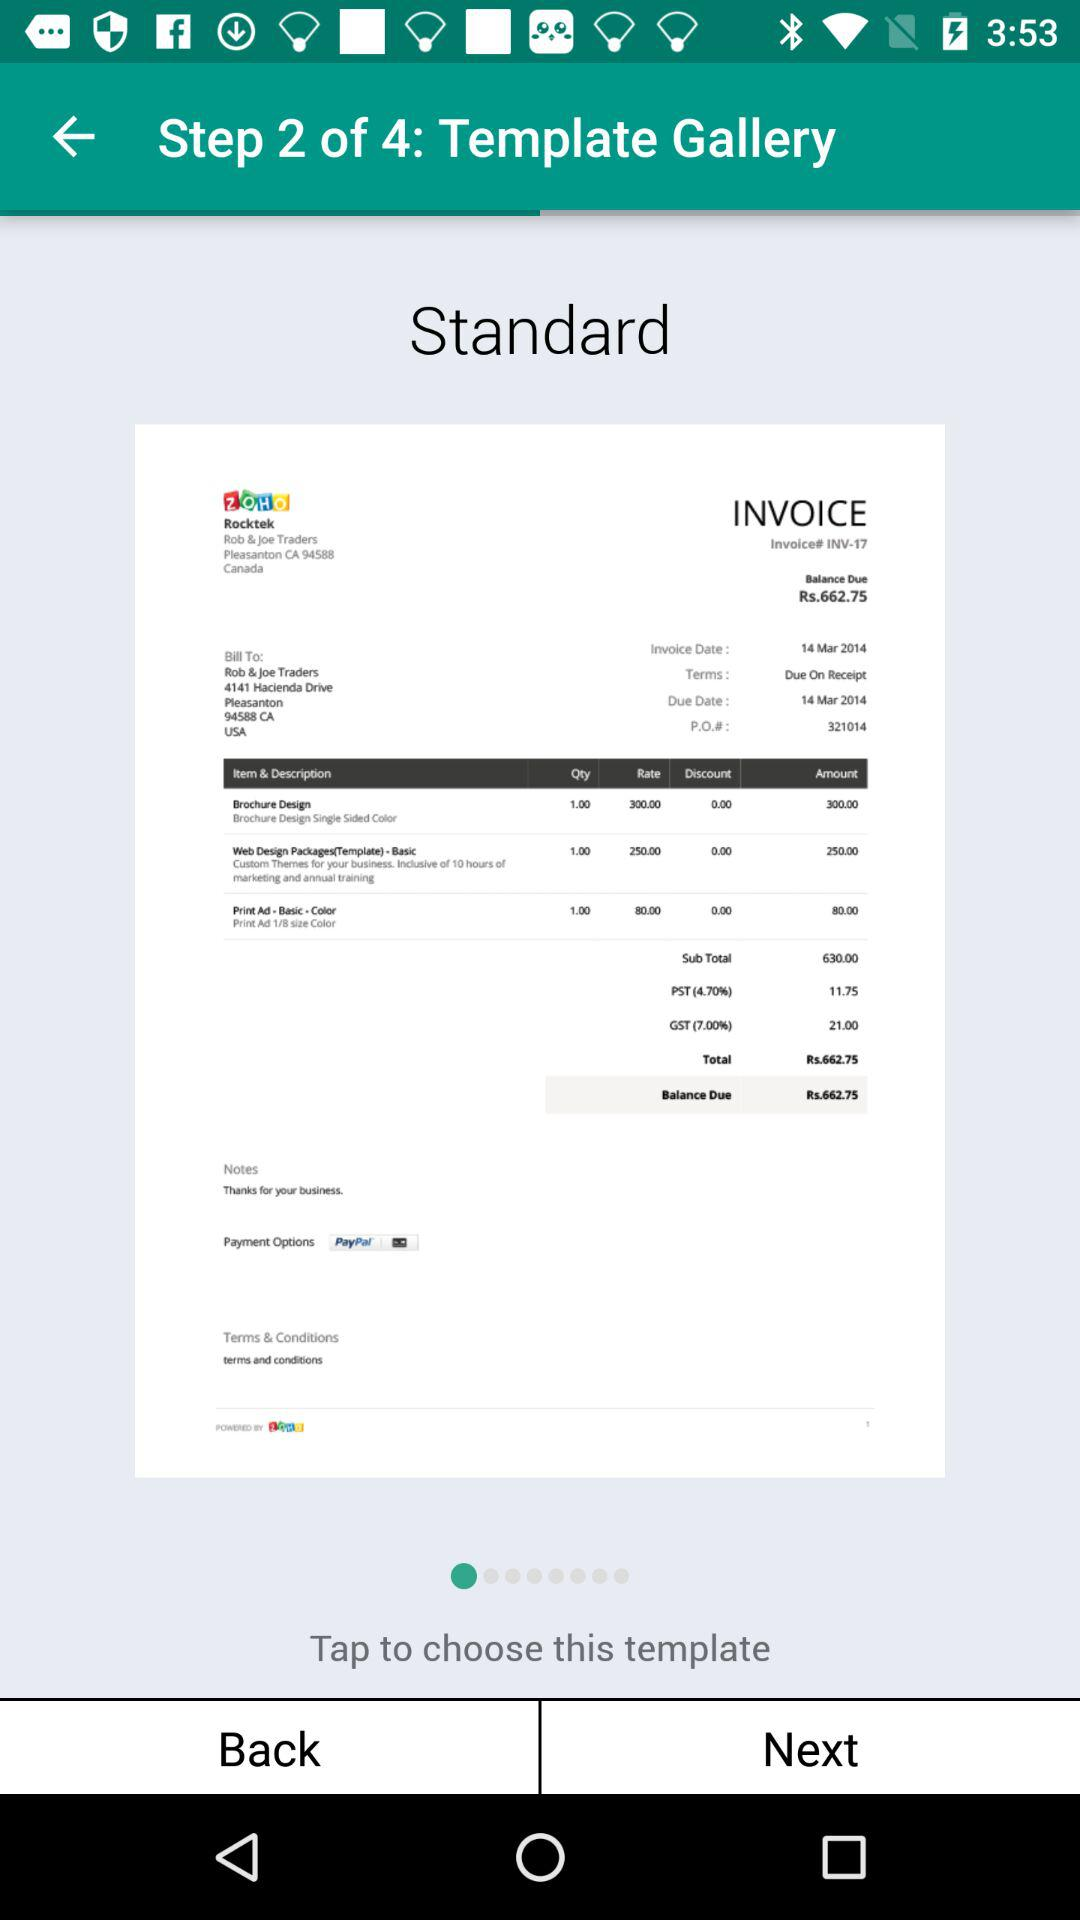How many steps are there in "Template Gallery"? There are 4 steps. 